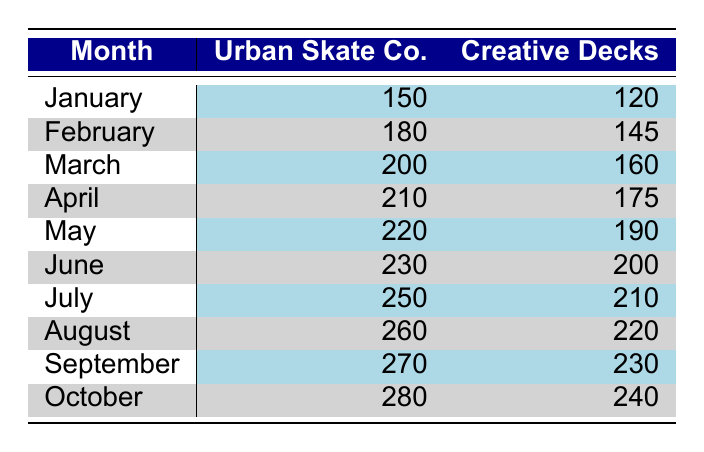What was the production output of Urban Skate Co. in October? According to the table, Urban Skate Co. produced 280 skateboard decks in October.
Answer: 280 What is the total production output for Creative Decks over the first six months? To find the total output for Creative Decks from January to June, we sum the monthly outputs: 120 + 145 + 160 + 175 + 190 + 200 = 1090.
Answer: 1090 Did Urban Skate Co. produce more than 250 decks in July? Yes, the table shows that Urban Skate Co. produced 250 decks in July, which is equal to 250, but not more.
Answer: No Which factory had a higher production output in August? In August, Urban Skate Co. produced 260 decks, while Creative Decks produced 220 decks. Therefore, Urban Skate Co. had a higher production output.
Answer: Urban Skate Co What was the difference in production output between Urban Skate Co. and Creative Decks in September? Urban Skate Co. produced 270 decks while Creative Decks produced 230 decks in September. The difference is 270 - 230 = 40.
Answer: 40 What was the average production output of Urban Skate Co. from January to March? Urban Skate Co.'s outputs for these months are 150 (January), 180 (February), and 200 (March). Summing these outputs gives 150 + 180 + 200 = 530. Dividing by 3 (the number of months) gives an average of 530 / 3 = approximately 176.67.
Answer: Approximately 176.67 Which month had the highest combined production output from both factories? To find this, we add the outputs for each month: January (150 + 120 = 270), February (180 + 145 = 325), March (200 + 160 = 360), April (210 + 175 = 385), May (220 + 190 = 410), June (230 + 200 = 430), July (250 + 210 = 460), August (260 + 220 = 480), September (270 + 230 = 500), and October (280 + 240 = 520). October has the highest combined output, 520.
Answer: October Was the production output for Creative Decks consistently increasing from January to October? No, the production outputs for Creative Decks in the first few months were 120, 145, 160, 175, 190, and 200, which increase, but in July it is 210, in August it is 220, in September it is 230, and in October it goes to 240, showing a consistent increase towards the end, but not throughout.
Answer: No 